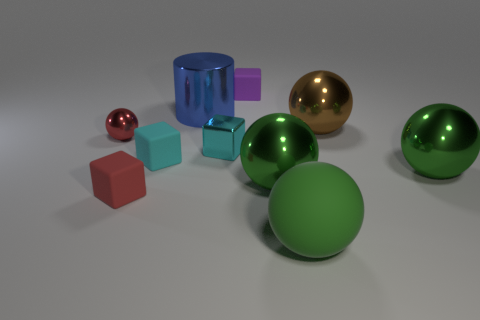How many green spheres must be subtracted to get 1 green spheres? 2 Subtract all brown blocks. How many green balls are left? 3 Subtract all red balls. How many balls are left? 4 Subtract all red shiny spheres. How many spheres are left? 4 Subtract 1 spheres. How many spheres are left? 4 Subtract all purple spheres. Subtract all brown cylinders. How many spheres are left? 5 Subtract all cylinders. How many objects are left? 9 Subtract all big green rubber spheres. Subtract all tiny red metal things. How many objects are left? 8 Add 1 large green balls. How many large green balls are left? 4 Add 1 big yellow matte balls. How many big yellow matte balls exist? 1 